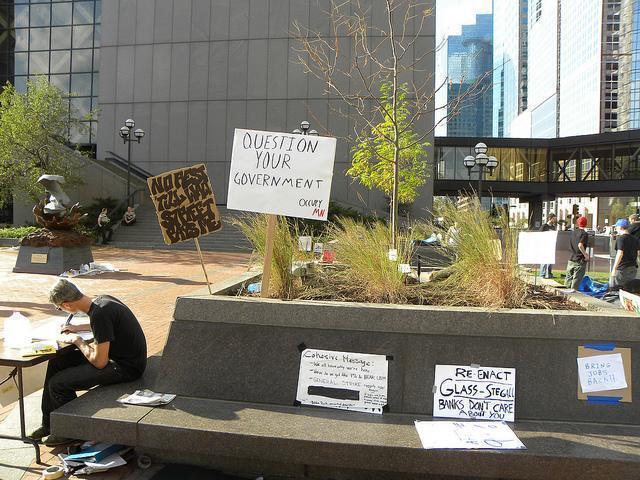What is the man participating in?
Indicate the correct response by choosing from the four available options to answer the question.
Options: Concert, sale, protest, play. Protest. 